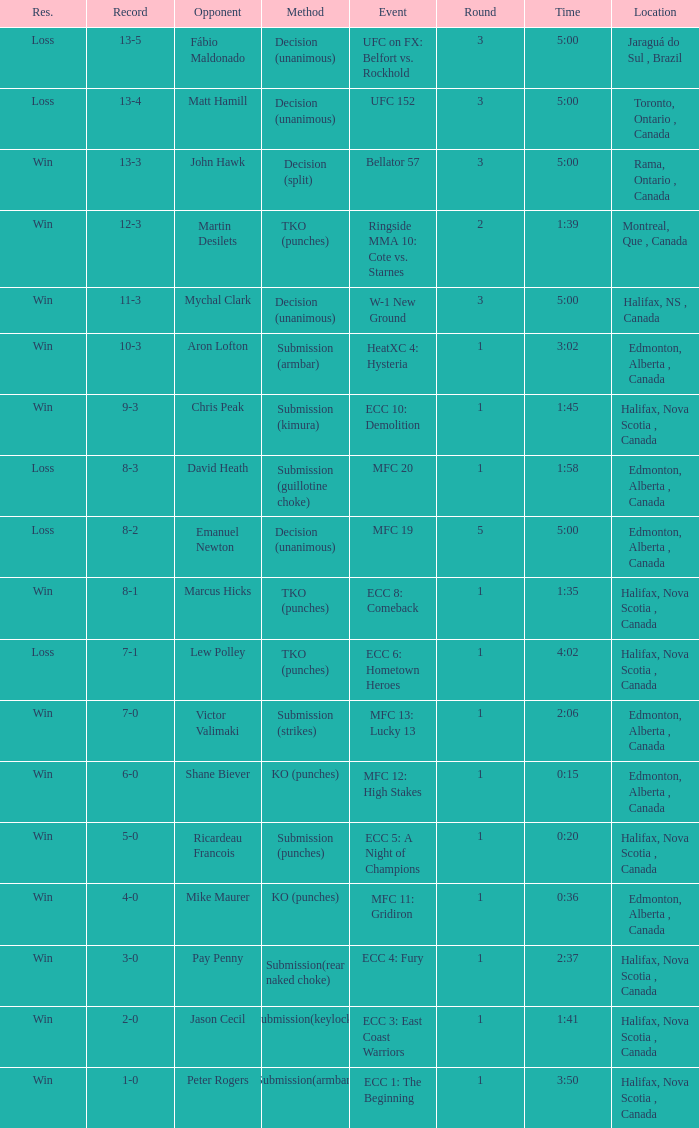What is the technique used in a match that has a single round and lasts for 1 minute and 58 seconds? Submission (guillotine choke). 